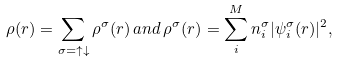Convert formula to latex. <formula><loc_0><loc_0><loc_500><loc_500>\rho ( { r } ) = \sum _ { \sigma = \uparrow \downarrow } \rho ^ { \sigma } ( { r } ) \, a n d \, \rho ^ { \sigma } ( { r } ) = \sum _ { i } ^ { M } n _ { i } ^ { \sigma } | \psi _ { i } ^ { \sigma } ( { r } ) | ^ { 2 } ,</formula> 